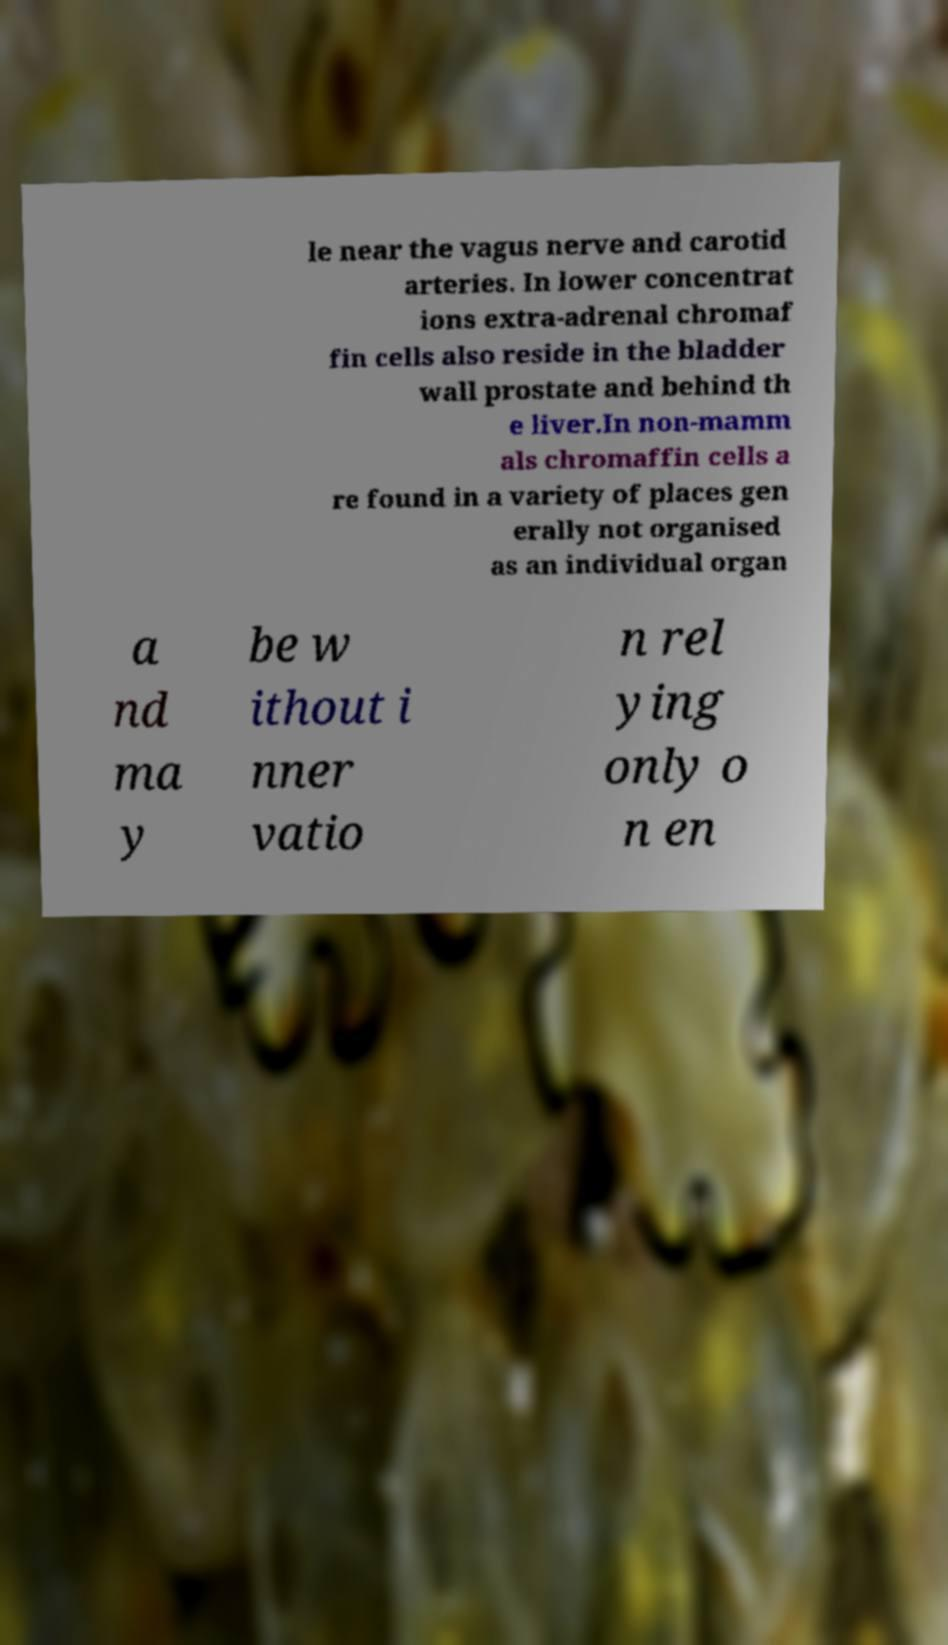Can you read and provide the text displayed in the image?This photo seems to have some interesting text. Can you extract and type it out for me? le near the vagus nerve and carotid arteries. In lower concentrat ions extra-adrenal chromaf fin cells also reside in the bladder wall prostate and behind th e liver.In non-mamm als chromaffin cells a re found in a variety of places gen erally not organised as an individual organ a nd ma y be w ithout i nner vatio n rel ying only o n en 